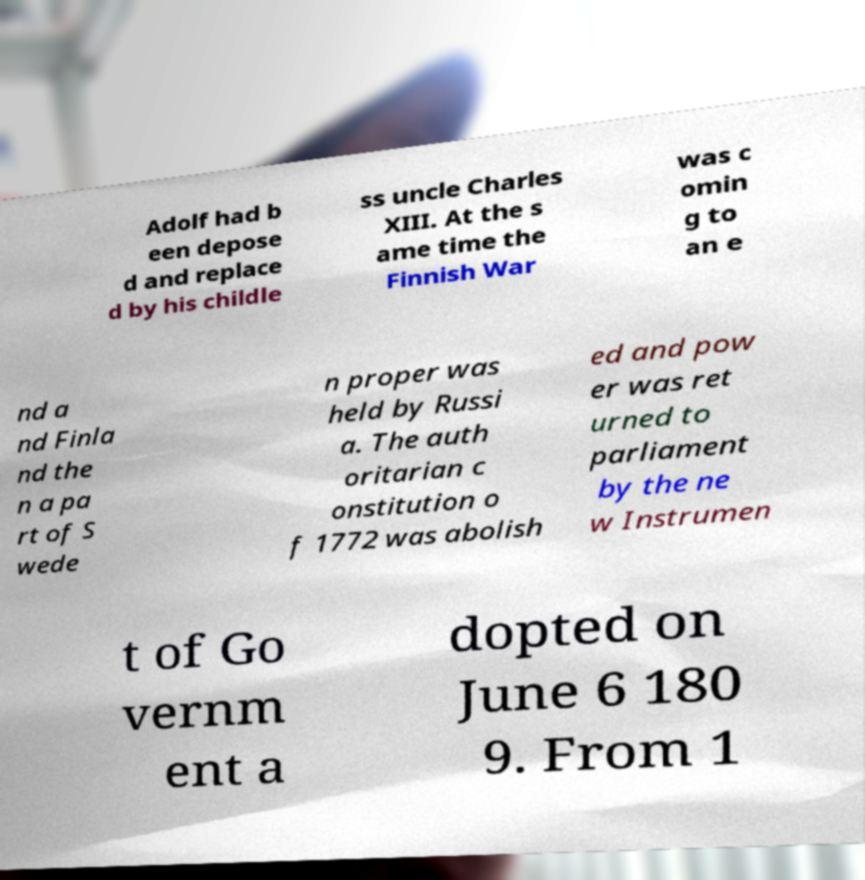Please read and relay the text visible in this image. What does it say? Adolf had b een depose d and replace d by his childle ss uncle Charles XIII. At the s ame time the Finnish War was c omin g to an e nd a nd Finla nd the n a pa rt of S wede n proper was held by Russi a. The auth oritarian c onstitution o f 1772 was abolish ed and pow er was ret urned to parliament by the ne w Instrumen t of Go vernm ent a dopted on June 6 180 9. From 1 